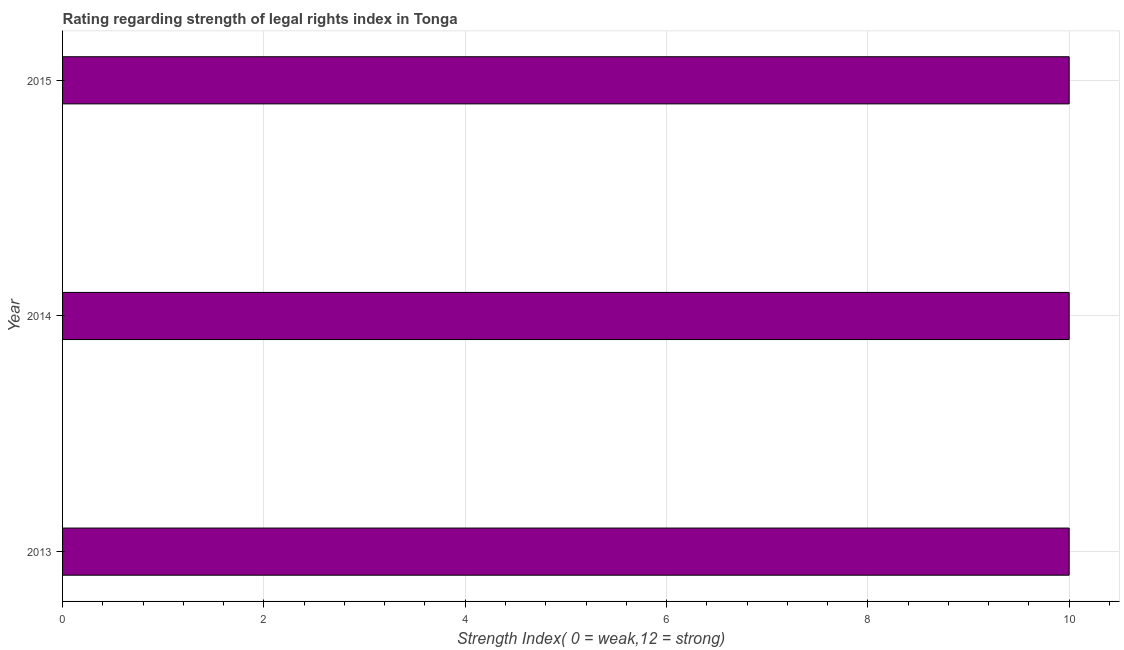What is the title of the graph?
Ensure brevity in your answer.  Rating regarding strength of legal rights index in Tonga. What is the label or title of the X-axis?
Your response must be concise. Strength Index( 0 = weak,12 = strong). What is the label or title of the Y-axis?
Keep it short and to the point. Year. What is the strength of legal rights index in 2014?
Keep it short and to the point. 10. In which year was the strength of legal rights index minimum?
Keep it short and to the point. 2013. What is the sum of the strength of legal rights index?
Provide a succinct answer. 30. What is the difference between the strength of legal rights index in 2013 and 2014?
Your answer should be compact. 0. What is the average strength of legal rights index per year?
Keep it short and to the point. 10. What is the median strength of legal rights index?
Offer a terse response. 10. In how many years, is the strength of legal rights index greater than 4.4 ?
Offer a very short reply. 3. What is the ratio of the strength of legal rights index in 2013 to that in 2015?
Ensure brevity in your answer.  1. Is the strength of legal rights index in 2014 less than that in 2015?
Offer a terse response. No. Is the sum of the strength of legal rights index in 2013 and 2015 greater than the maximum strength of legal rights index across all years?
Keep it short and to the point. Yes. What is the difference between the highest and the lowest strength of legal rights index?
Your answer should be compact. 0. In how many years, is the strength of legal rights index greater than the average strength of legal rights index taken over all years?
Offer a terse response. 0. What is the difference between two consecutive major ticks on the X-axis?
Your answer should be very brief. 2. What is the Strength Index( 0 = weak,12 = strong) in 2013?
Keep it short and to the point. 10. What is the Strength Index( 0 = weak,12 = strong) of 2014?
Make the answer very short. 10. What is the difference between the Strength Index( 0 = weak,12 = strong) in 2013 and 2014?
Offer a very short reply. 0. What is the difference between the Strength Index( 0 = weak,12 = strong) in 2014 and 2015?
Offer a terse response. 0. What is the ratio of the Strength Index( 0 = weak,12 = strong) in 2013 to that in 2014?
Offer a very short reply. 1. 